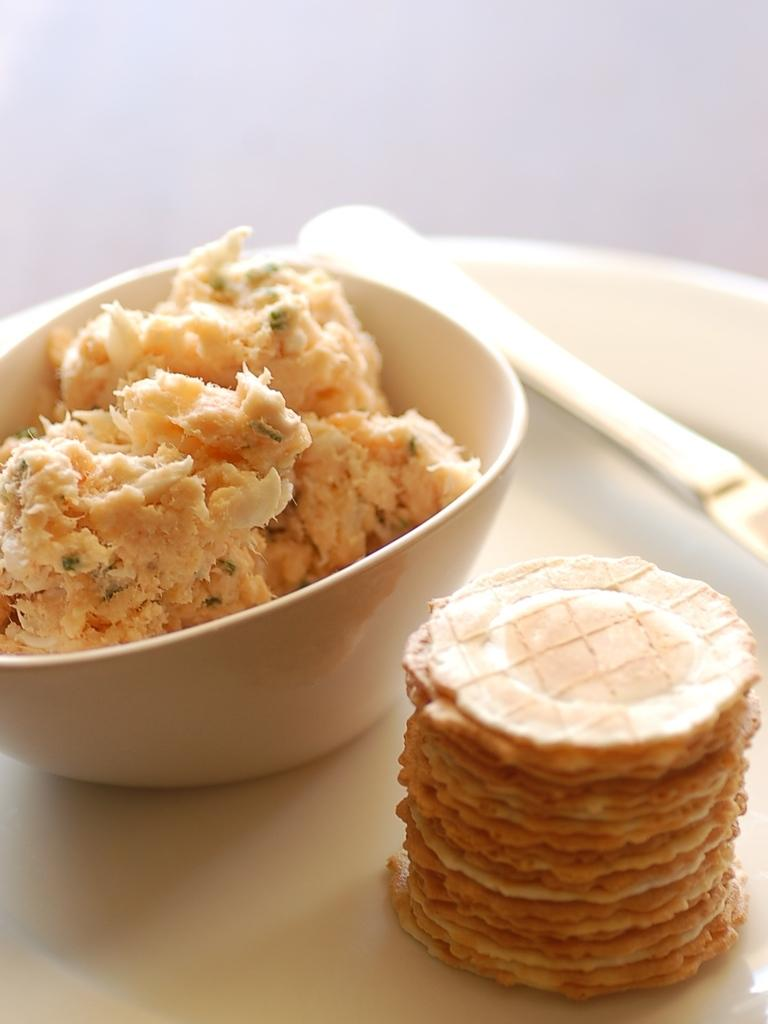What is in the bowl that is visible in the image? There is a bowl of food items in the image. What other food items can be seen in the image? There are food items on a white plate in the image. What utensil is present with the food items on the plate? There is a spoon on the white plate in the image. What type of door can be seen in the image? There is no door present in the image; it features a bowl of food items and food items on a white plate with a spoon. 